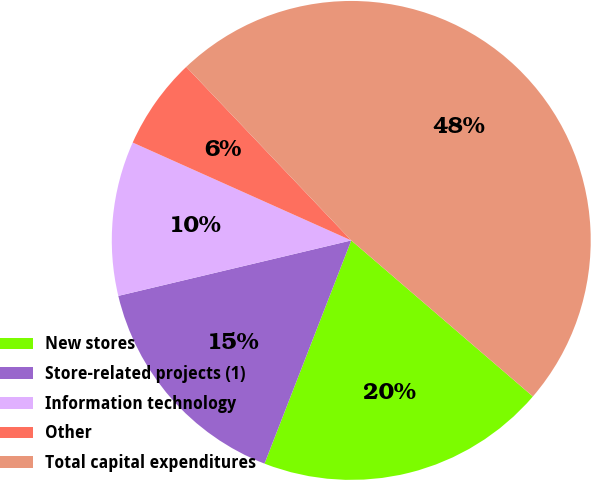Convert chart to OTSL. <chart><loc_0><loc_0><loc_500><loc_500><pie_chart><fcel>New stores<fcel>Store-related projects (1)<fcel>Information technology<fcel>Other<fcel>Total capital expenditures<nl><fcel>19.6%<fcel>15.38%<fcel>10.42%<fcel>6.2%<fcel>48.39%<nl></chart> 